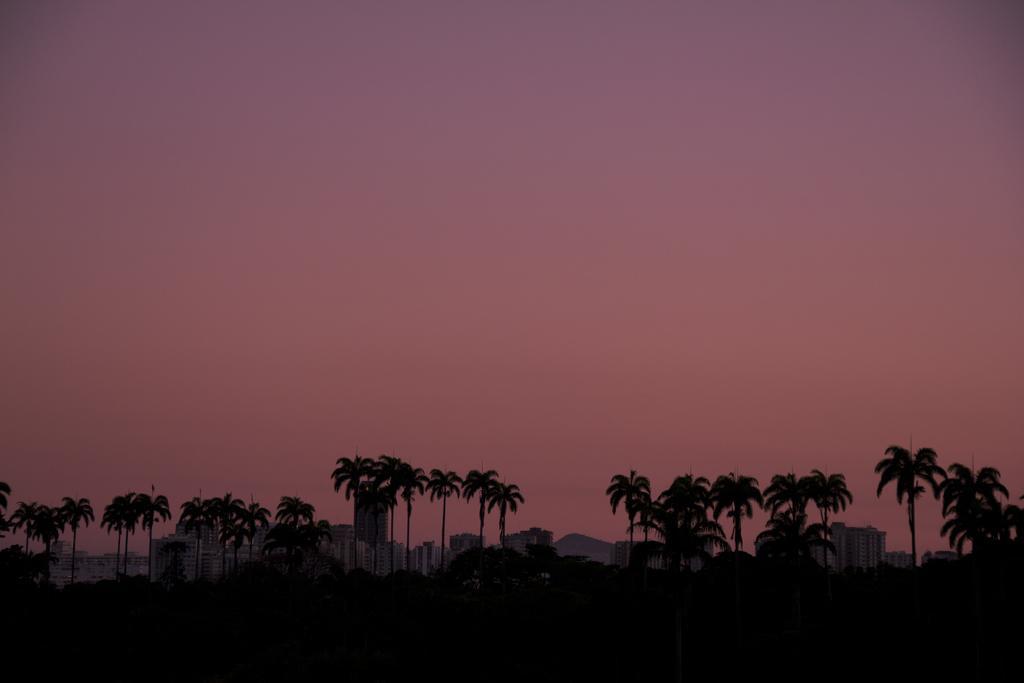Please provide a concise description of this image. As we can see in the image there are trees and buildings. On the top there is sky. 